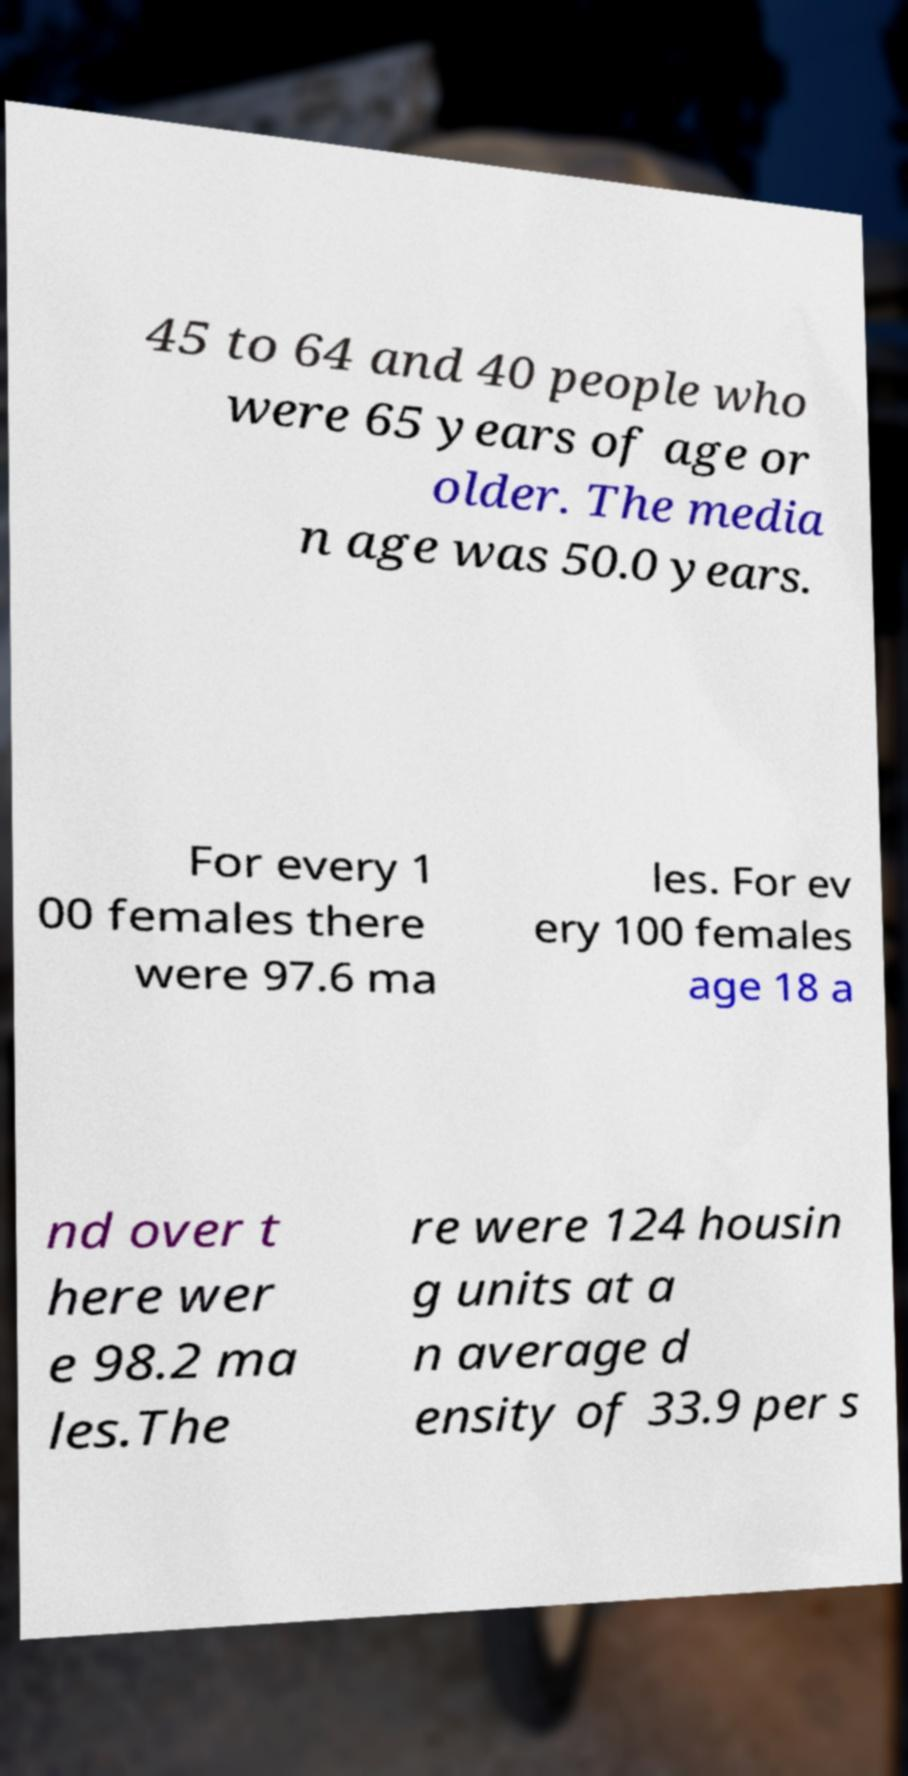Could you extract and type out the text from this image? 45 to 64 and 40 people who were 65 years of age or older. The media n age was 50.0 years. For every 1 00 females there were 97.6 ma les. For ev ery 100 females age 18 a nd over t here wer e 98.2 ma les.The re were 124 housin g units at a n average d ensity of 33.9 per s 